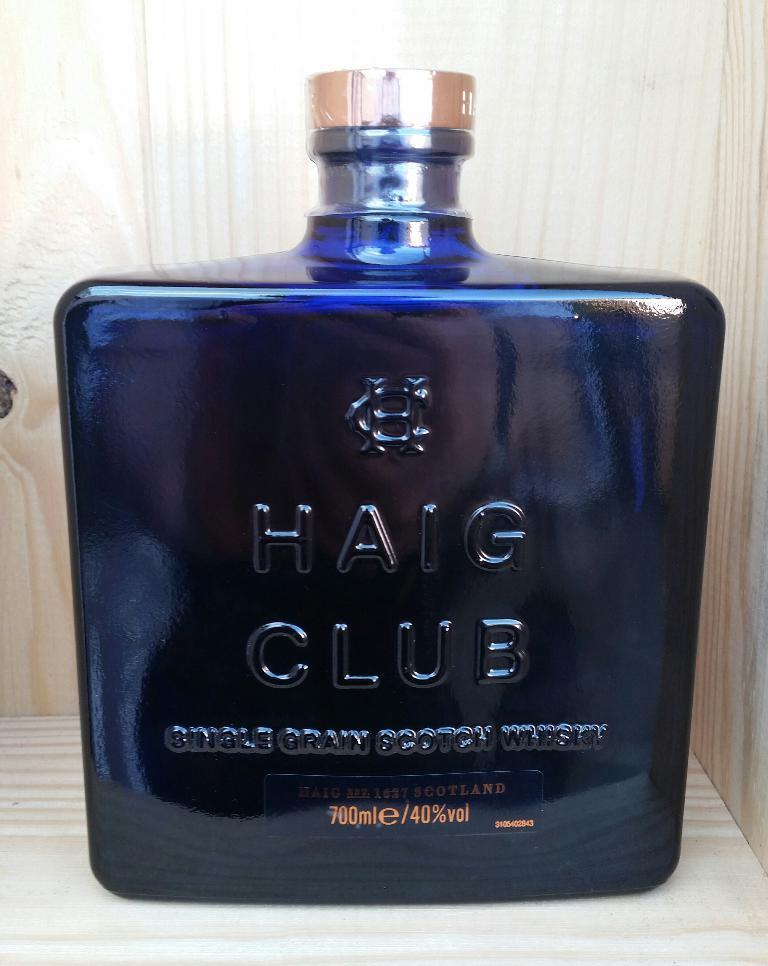<image>
Summarize the visual content of the image. the word Haig is on the blue item 